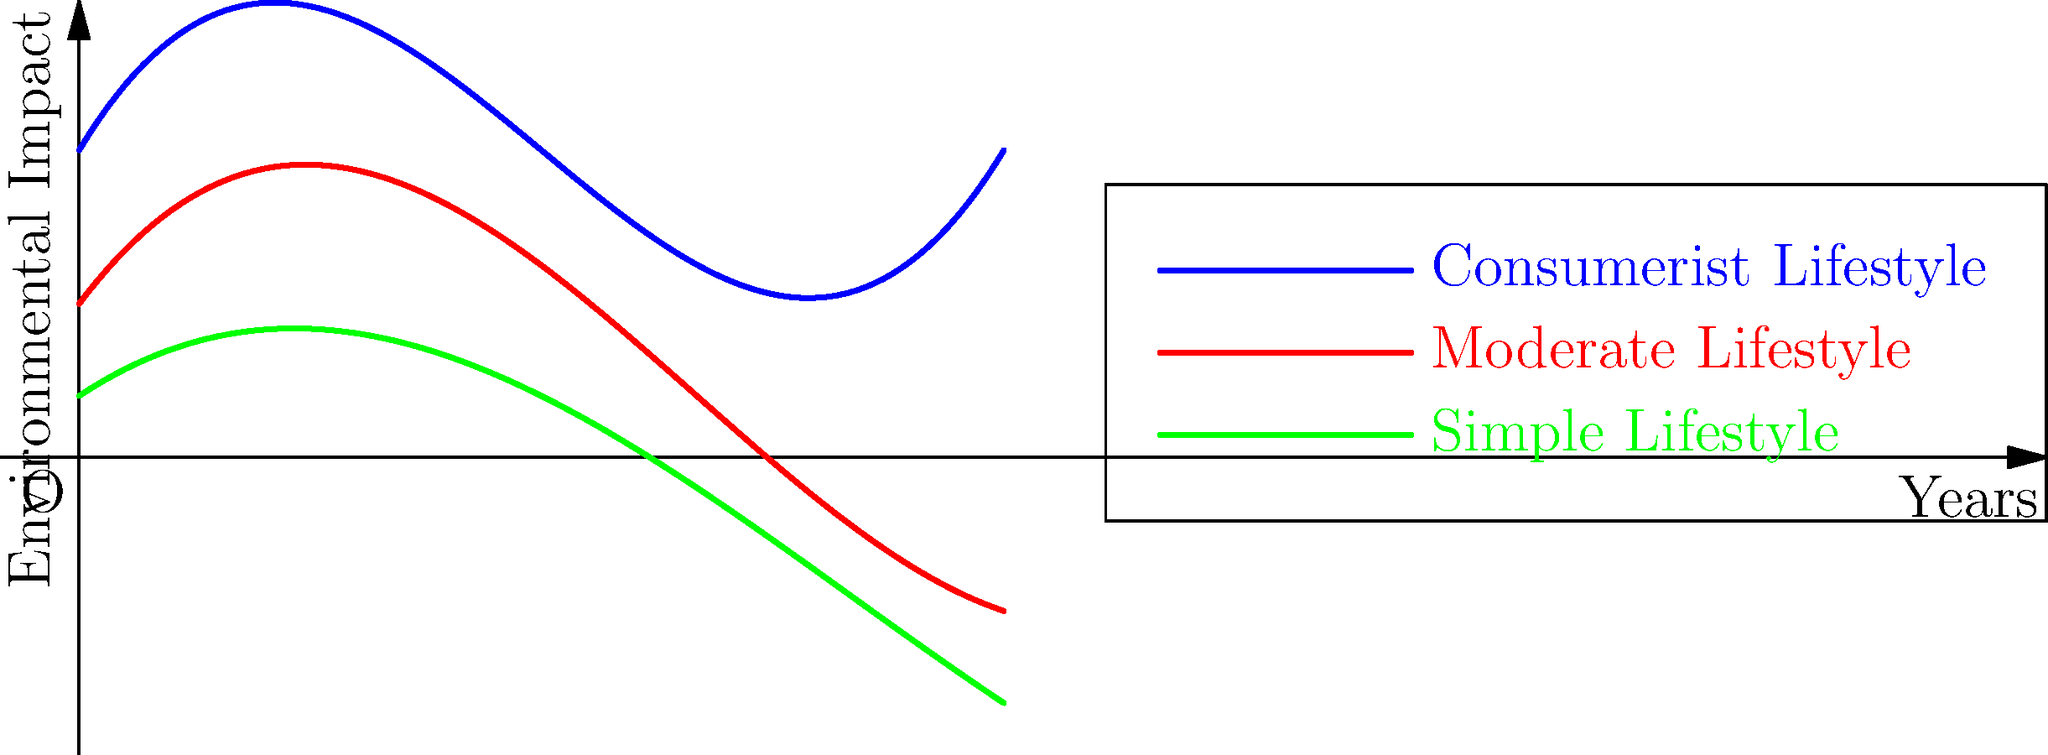The graph shows the environmental impact of three different lifestyles over time. Which lifestyle aligns most closely with our teachings on stewardship of the Earth, and why does its curve behave differently from the others? To answer this question, we need to analyze the three curves:

1. Blue curve (Consumerist Lifestyle): Shows the steepest increase in environmental impact over time.
2. Red curve (Moderate Lifestyle): Shows a moderate increase in environmental impact.
3. Green curve (Simple Lifestyle): Shows the slowest increase in environmental impact.

The green curve, representing the Simple Lifestyle, aligns most closely with our teachings on stewardship of the Earth. Here's why its curve behaves differently:

1. Initial impact: The green curve starts at the lowest point, indicating a lower initial environmental impact.

2. Rate of increase: The slope of the green curve is less steep compared to the other two, suggesting a slower rate of environmental impact increase over time.

3. Polynomial nature: All curves are polynomial, but the green curve's coefficients are smaller:
   - Simple Lifestyle: $f(x) = 0.02x^3 - 0.5x^2 + 2x + 2$
   - Moderate Lifestyle: $g(x) = 0.05x^3 - x^2 + 4x + 5$
   - Consumerist Lifestyle: $h(x) = 0.1x^3 - 1.5x^2 + 5x + 10$

4. Long-term impact: Even after 10 years, the Simple Lifestyle maintains the lowest environmental impact.

This behavior reflects the principles of a humble and simple life, which emphasizes minimizing consumption, reducing waste, and living in harmony with nature. Such a lifestyle naturally leads to a slower accumulation of environmental impact over time.
Answer: Simple Lifestyle (green curve); lowest coefficients in polynomial equation, indicating slower increase in environmental impact over time. 